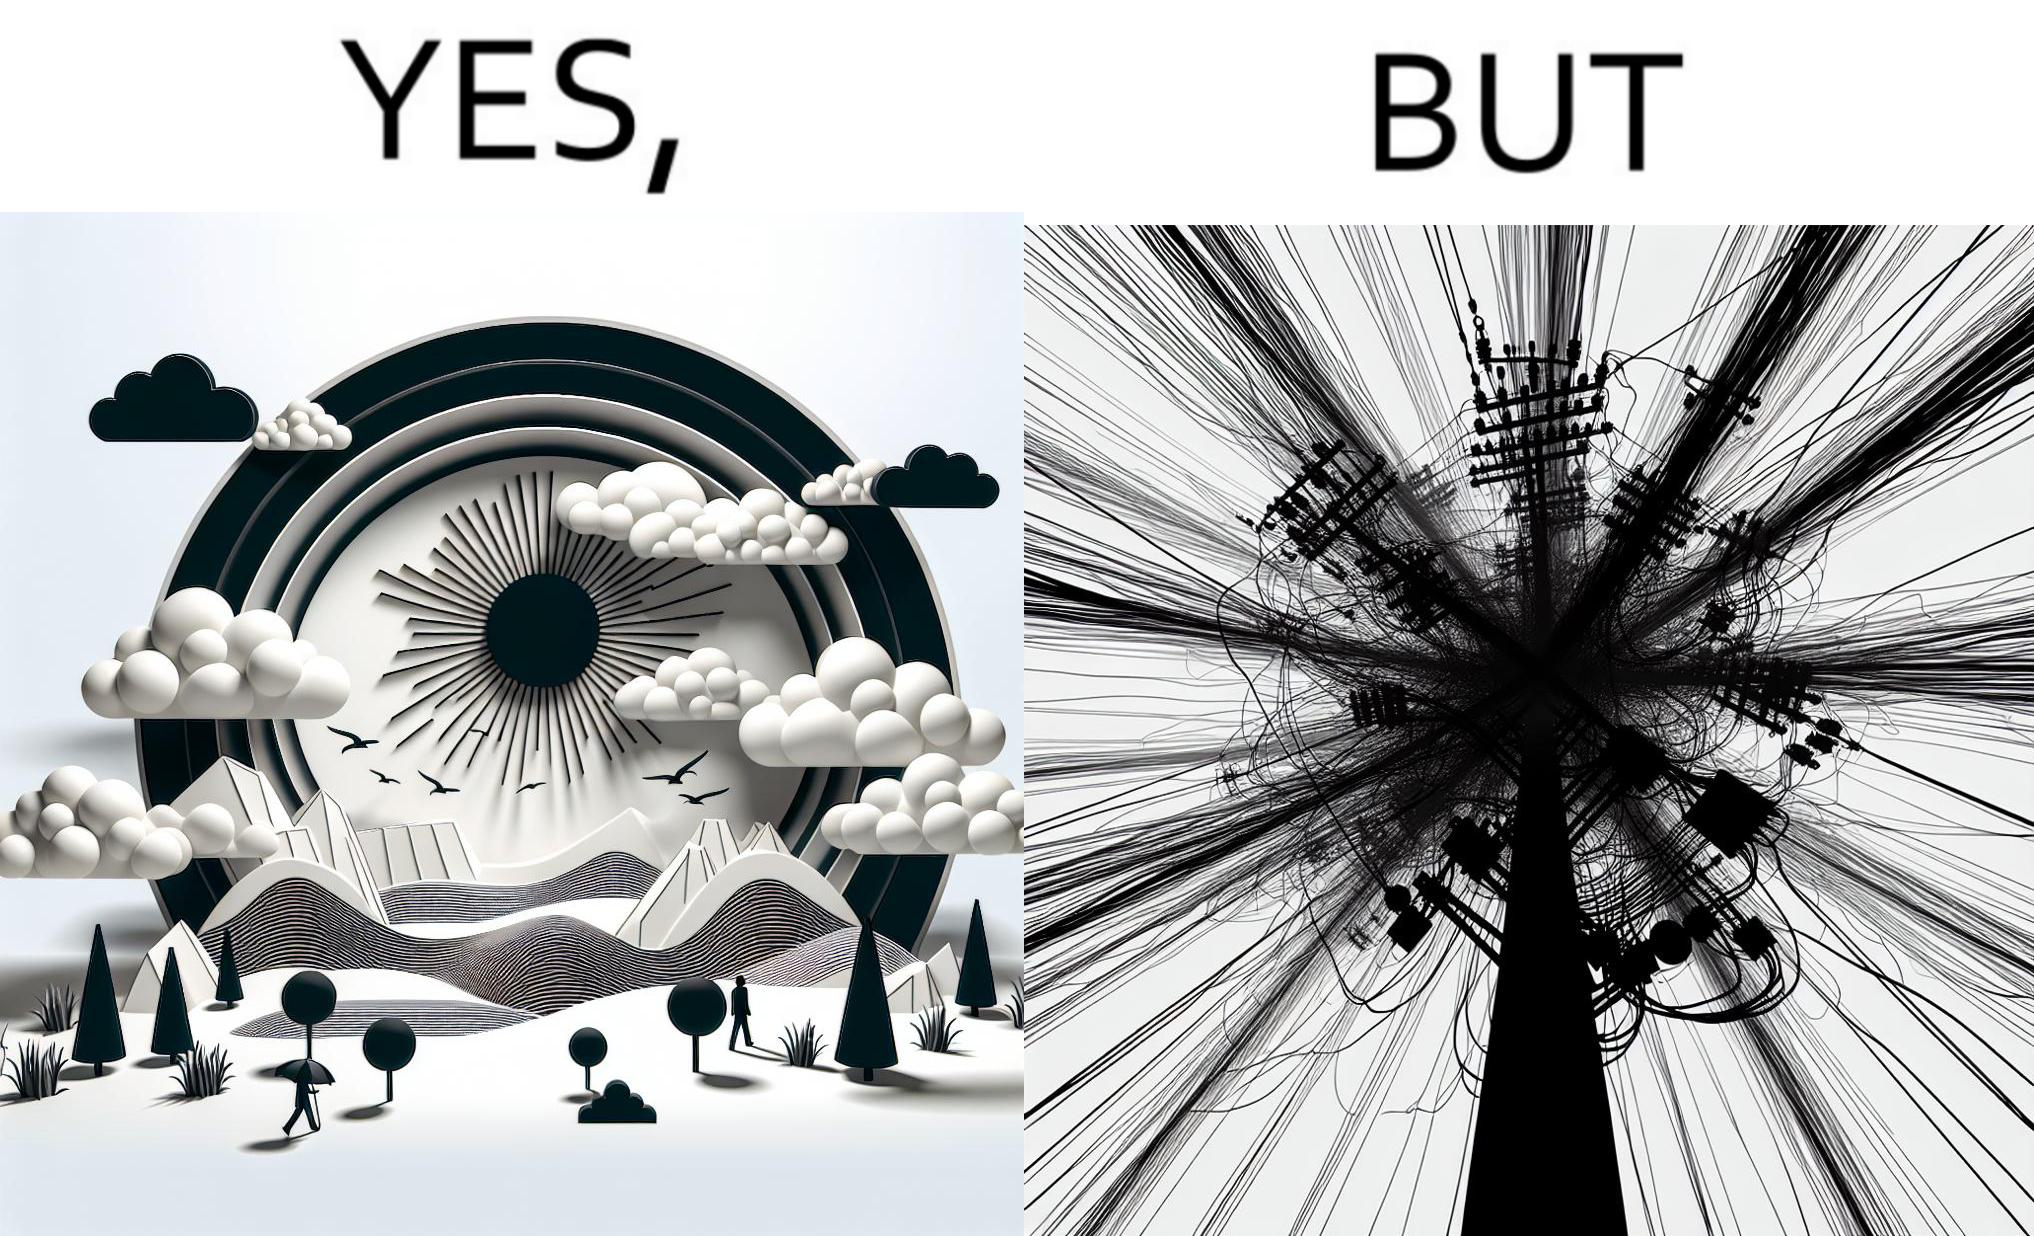Explain the humor or irony in this image. The image is ironic, because in the first image clear sky is visible but in the second image the same view is getting blocked due to the electricity pole 